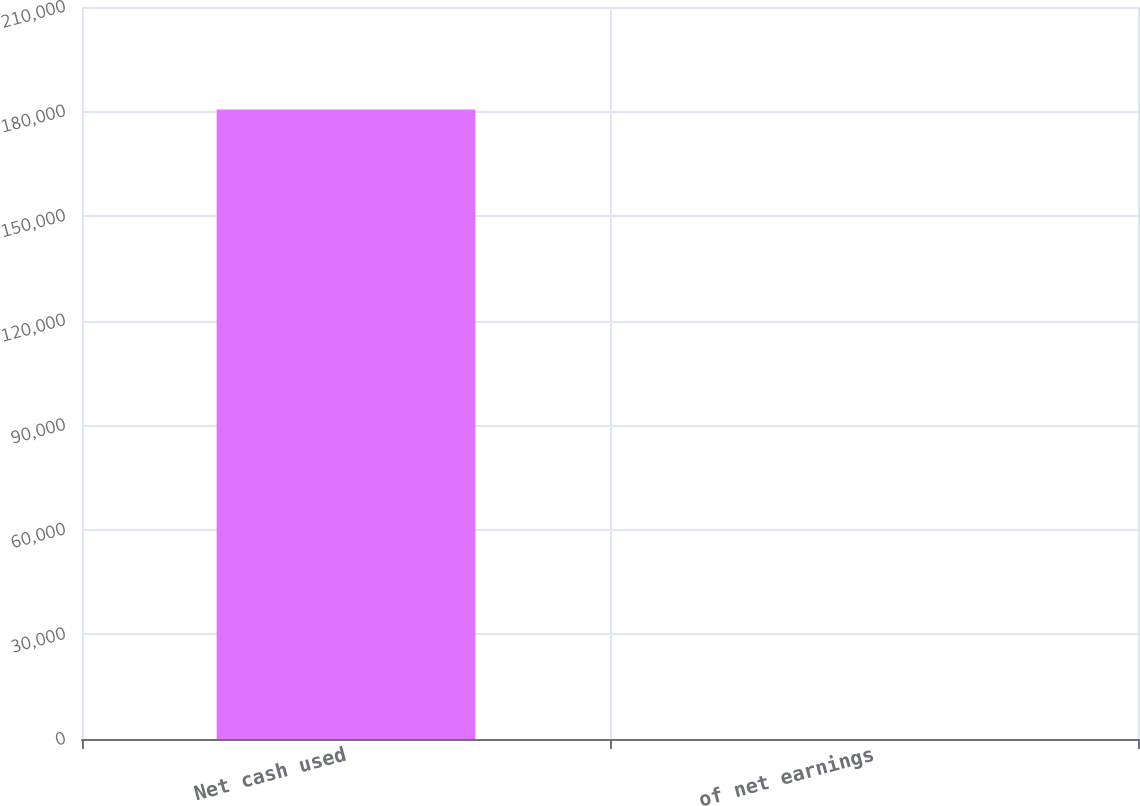Convert chart. <chart><loc_0><loc_0><loc_500><loc_500><bar_chart><fcel>Net cash used<fcel>of net earnings<nl><fcel>180627<fcel>35<nl></chart> 